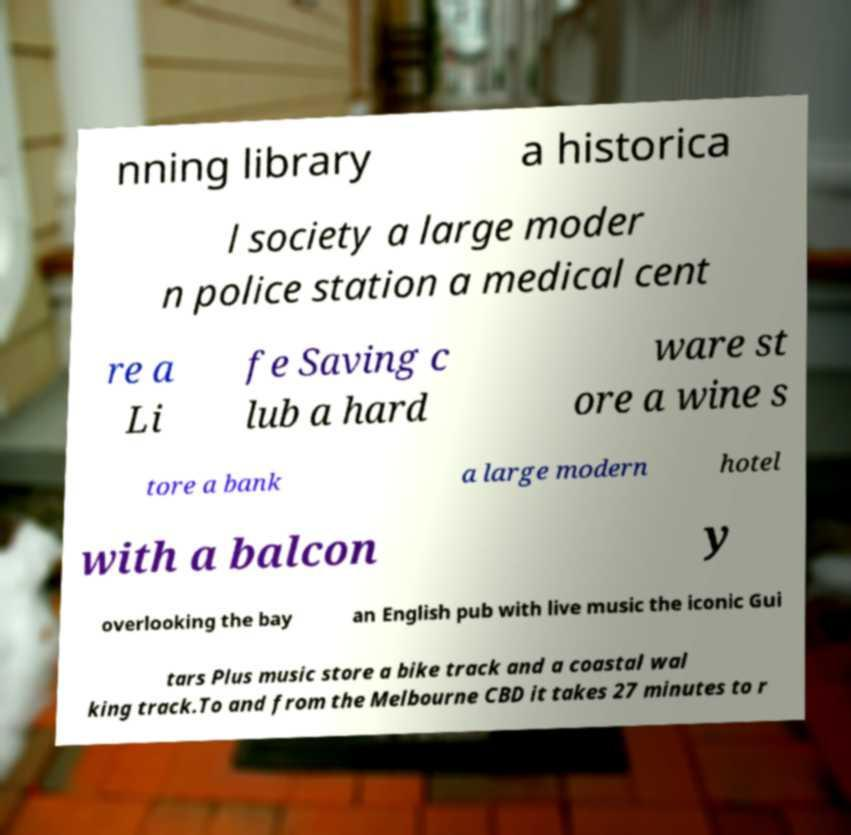Please identify and transcribe the text found in this image. nning library a historica l society a large moder n police station a medical cent re a Li fe Saving c lub a hard ware st ore a wine s tore a bank a large modern hotel with a balcon y overlooking the bay an English pub with live music the iconic Gui tars Plus music store a bike track and a coastal wal king track.To and from the Melbourne CBD it takes 27 minutes to r 